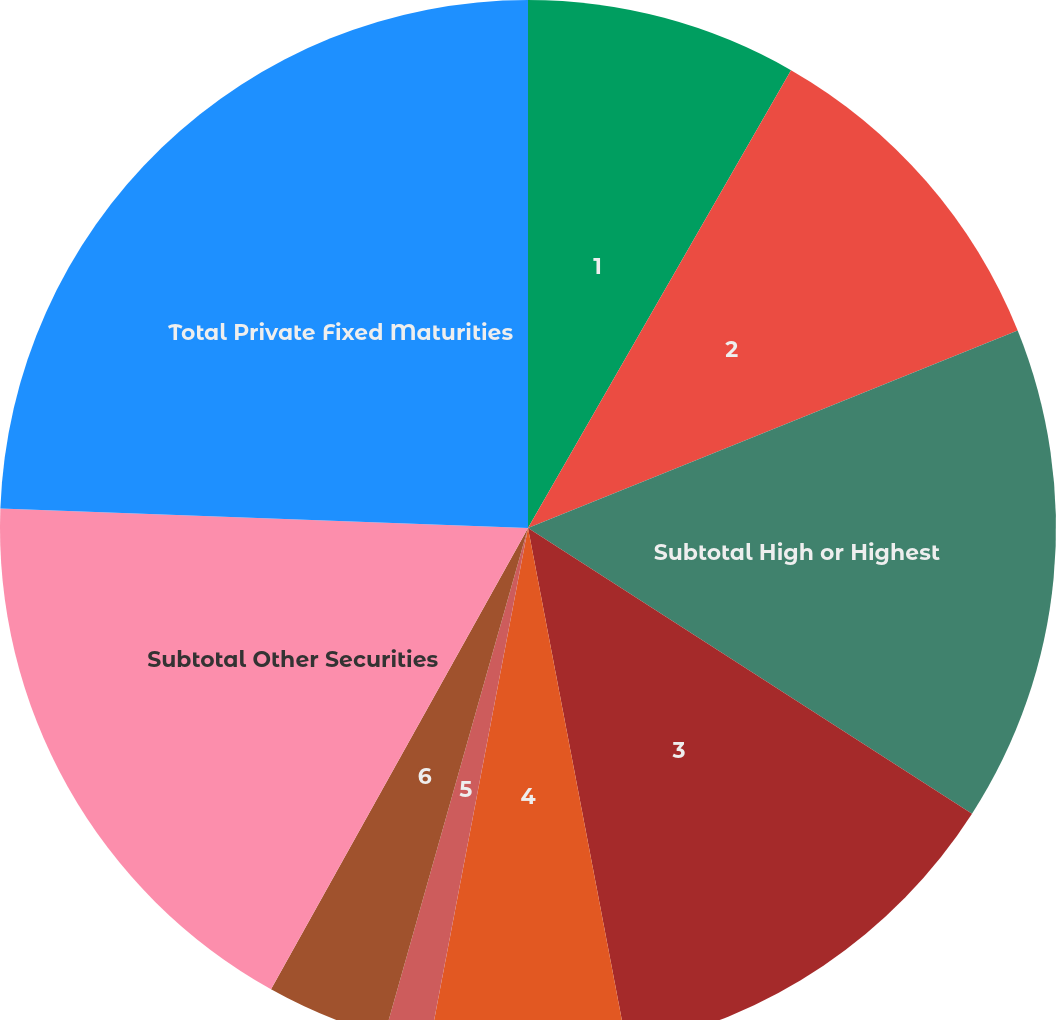Convert chart to OTSL. <chart><loc_0><loc_0><loc_500><loc_500><pie_chart><fcel>1<fcel>2<fcel>Subtotal High or Highest<fcel>3<fcel>4<fcel>5<fcel>6<fcel>Subtotal Other Securities<fcel>Total Private Fixed Maturities<nl><fcel>8.3%<fcel>10.6%<fcel>15.2%<fcel>12.9%<fcel>6.0%<fcel>1.39%<fcel>3.7%<fcel>17.5%<fcel>24.41%<nl></chart> 